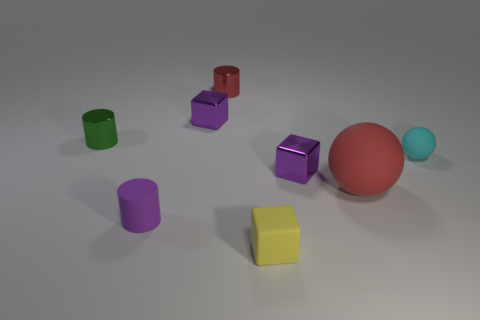How many metallic objects have the same color as the matte cube?
Offer a very short reply. 0. Is the color of the rubber cylinder the same as the small shiny thing right of the tiny yellow cube?
Your answer should be compact. Yes. What number of objects are small red rubber things or tiny blocks in front of the small green shiny cylinder?
Keep it short and to the point. 2. There is a purple object on the right side of the cube that is behind the green metal thing; what size is it?
Your answer should be very brief. Small. Are there the same number of small yellow cubes that are behind the large red object and things that are left of the small green metallic cylinder?
Offer a terse response. Yes. Are there any small metallic things to the left of the tiny shiny object that is left of the purple cylinder?
Your response must be concise. No. There is a tiny red thing that is the same material as the tiny green cylinder; what shape is it?
Your answer should be compact. Cylinder. Is there anything else that is the same color as the tiny rubber cylinder?
Provide a succinct answer. Yes. What material is the tiny cylinder on the left side of the small purple matte cylinder that is in front of the green metal object?
Your answer should be compact. Metal. Is there another metallic thing that has the same shape as the large red thing?
Your answer should be compact. No. 